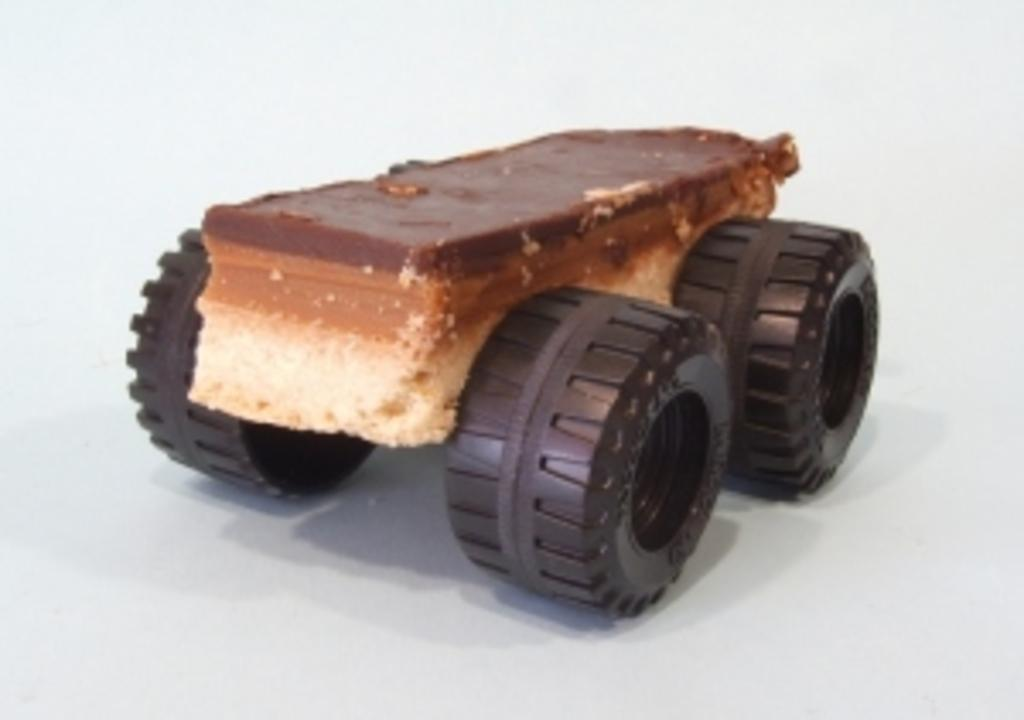What is the main subject of the image? There is a cake in the image. Where is the cake located? The cake is on a toy. How many cows are present in the image? There are no cows present in the image; it features a cake on a toy. What type of writing instrument is used by the crown in the image? There is no crown or writing instrument present in the image. 